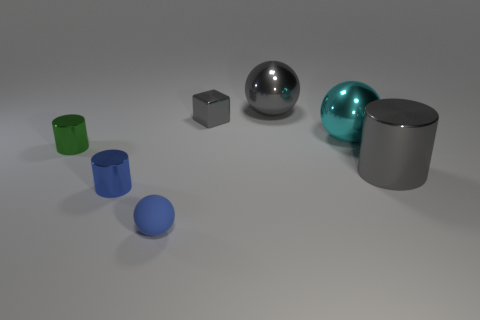Is there anything else that has the same material as the tiny blue sphere?
Offer a terse response. No. What number of objects are either green metal objects or big gray cylinders?
Give a very brief answer. 2. What size is the metal cylinder that is the same color as the small cube?
Your answer should be compact. Large. Are there any large gray things in front of the green metal cylinder?
Your answer should be very brief. Yes. Are there more tiny blue objects to the right of the tiny blue metallic cylinder than small balls right of the gray sphere?
Give a very brief answer. Yes. The gray object that is the same shape as the small blue matte thing is what size?
Ensure brevity in your answer.  Large. What number of blocks are green metallic objects or large cyan objects?
Provide a succinct answer. 0. There is a cylinder that is the same color as the small sphere; what is it made of?
Offer a very short reply. Metal. Are there fewer small gray metal objects in front of the small blue shiny cylinder than tiny objects to the right of the matte object?
Your answer should be very brief. Yes. How many objects are small blue objects that are behind the tiny blue matte sphere or large balls?
Offer a very short reply. 3. 